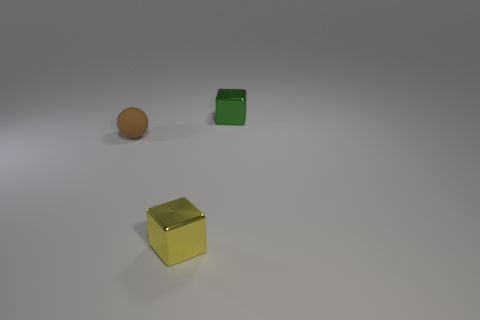How many tiny objects are brown things or blue shiny balls?
Provide a succinct answer. 1. Are there more green metal things than green shiny cylinders?
Your answer should be very brief. Yes. Is the brown sphere made of the same material as the yellow block?
Provide a succinct answer. No. Are there any other things that are the same material as the tiny brown ball?
Your response must be concise. No. Are there more small brown spheres that are on the left side of the yellow block than large shiny cubes?
Ensure brevity in your answer.  Yes. What number of green metallic objects have the same shape as the tiny yellow metal object?
Offer a terse response. 1. What color is the small thing that is behind the yellow cube and to the right of the brown rubber object?
Provide a succinct answer. Green. How many matte spheres are the same size as the yellow cube?
Offer a terse response. 1. How many metal objects are right of the tiny brown object in front of the tiny metal cube that is behind the tiny brown object?
Your response must be concise. 2. The ball that is the same size as the green metal thing is what color?
Provide a short and direct response. Brown. 